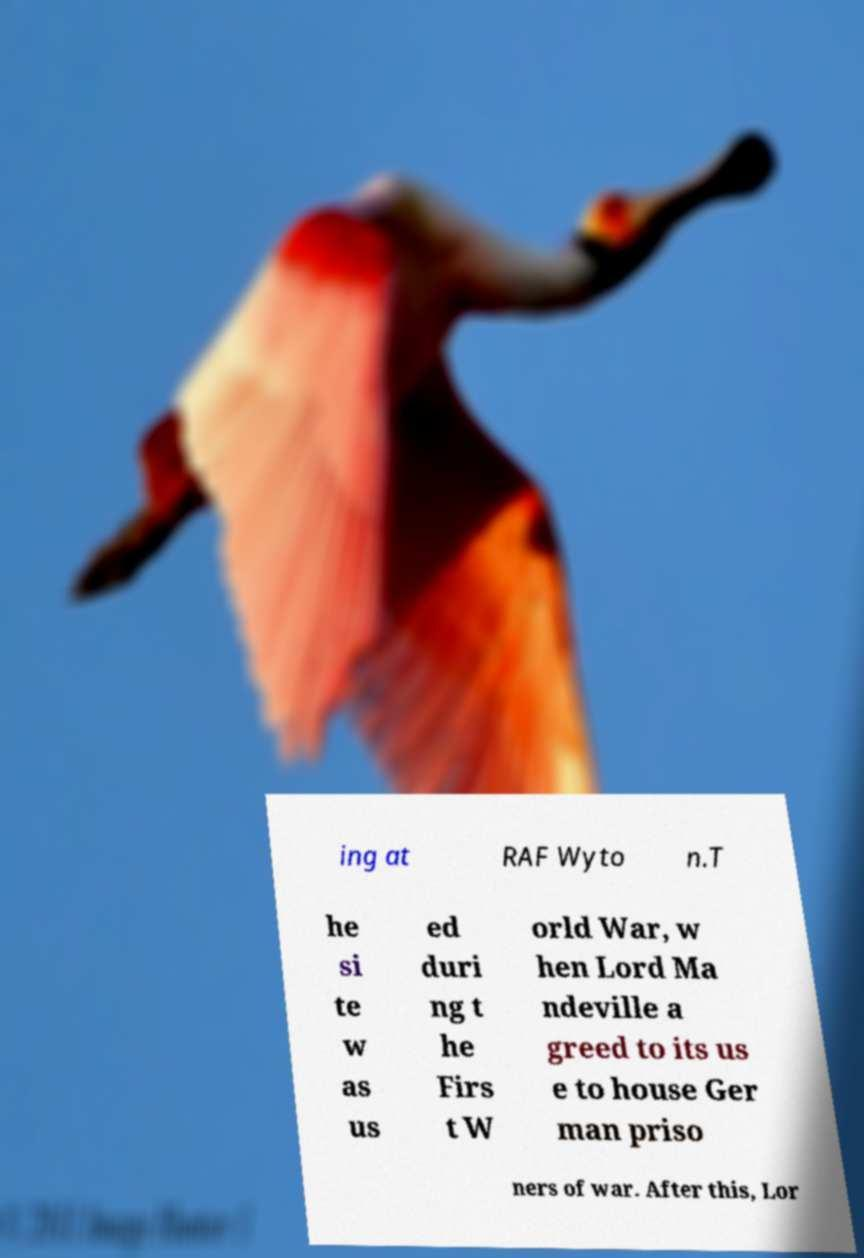There's text embedded in this image that I need extracted. Can you transcribe it verbatim? ing at RAF Wyto n.T he si te w as us ed duri ng t he Firs t W orld War, w hen Lord Ma ndeville a greed to its us e to house Ger man priso ners of war. After this, Lor 